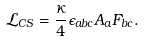<formula> <loc_0><loc_0><loc_500><loc_500>\mathcal { L } _ { C S } = \frac { \kappa } { 4 } \epsilon _ { a b c } A _ { a } F _ { b c } .</formula> 